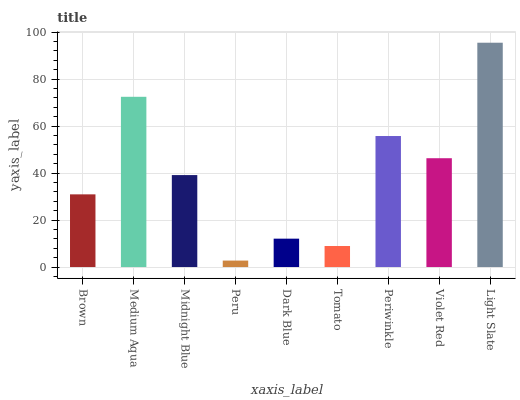Is Peru the minimum?
Answer yes or no. Yes. Is Light Slate the maximum?
Answer yes or no. Yes. Is Medium Aqua the minimum?
Answer yes or no. No. Is Medium Aqua the maximum?
Answer yes or no. No. Is Medium Aqua greater than Brown?
Answer yes or no. Yes. Is Brown less than Medium Aqua?
Answer yes or no. Yes. Is Brown greater than Medium Aqua?
Answer yes or no. No. Is Medium Aqua less than Brown?
Answer yes or no. No. Is Midnight Blue the high median?
Answer yes or no. Yes. Is Midnight Blue the low median?
Answer yes or no. Yes. Is Violet Red the high median?
Answer yes or no. No. Is Tomato the low median?
Answer yes or no. No. 